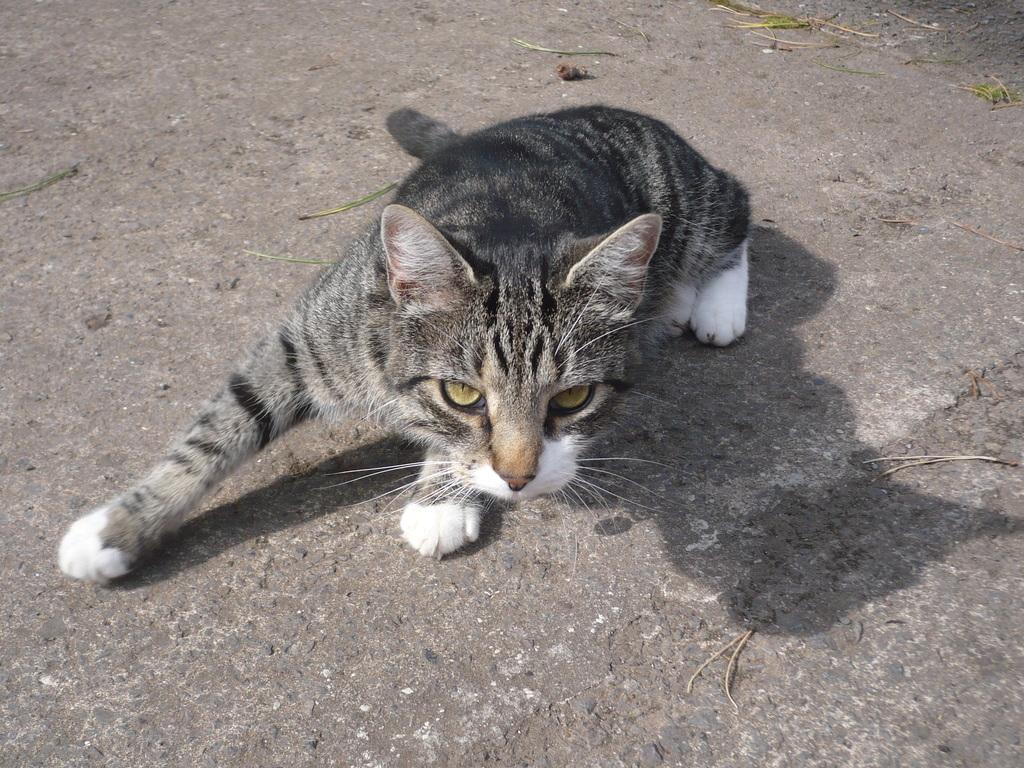What type of animal is in the image? There is a cat in the image. Where is the cat located in the image? The cat is in the center of the image. What type of produce is the cat holding in the image? There is no produce present in the image; the cat is not holding anything. 